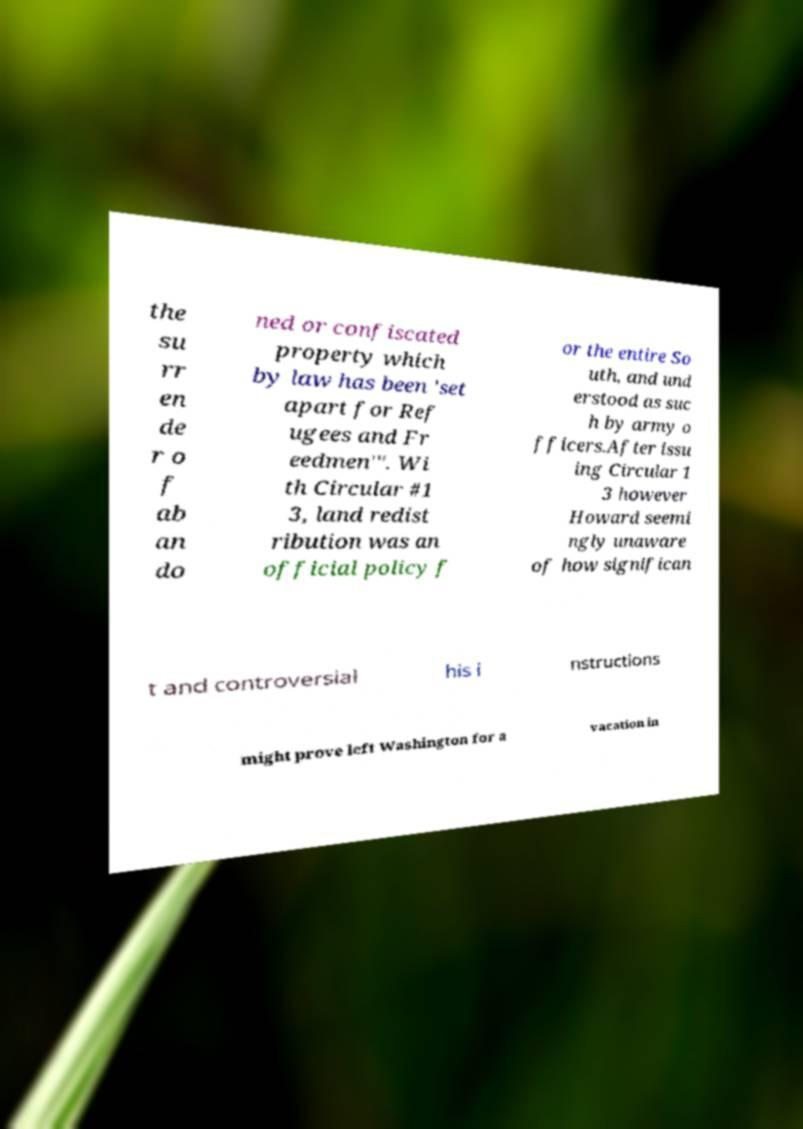Could you assist in decoding the text presented in this image and type it out clearly? the su rr en de r o f ab an do ned or confiscated property which by law has been 'set apart for Ref ugees and Fr eedmen'". Wi th Circular #1 3, land redist ribution was an official policy f or the entire So uth, and und erstood as suc h by army o fficers.After issu ing Circular 1 3 however Howard seemi ngly unaware of how significan t and controversial his i nstructions might prove left Washington for a vacation in 